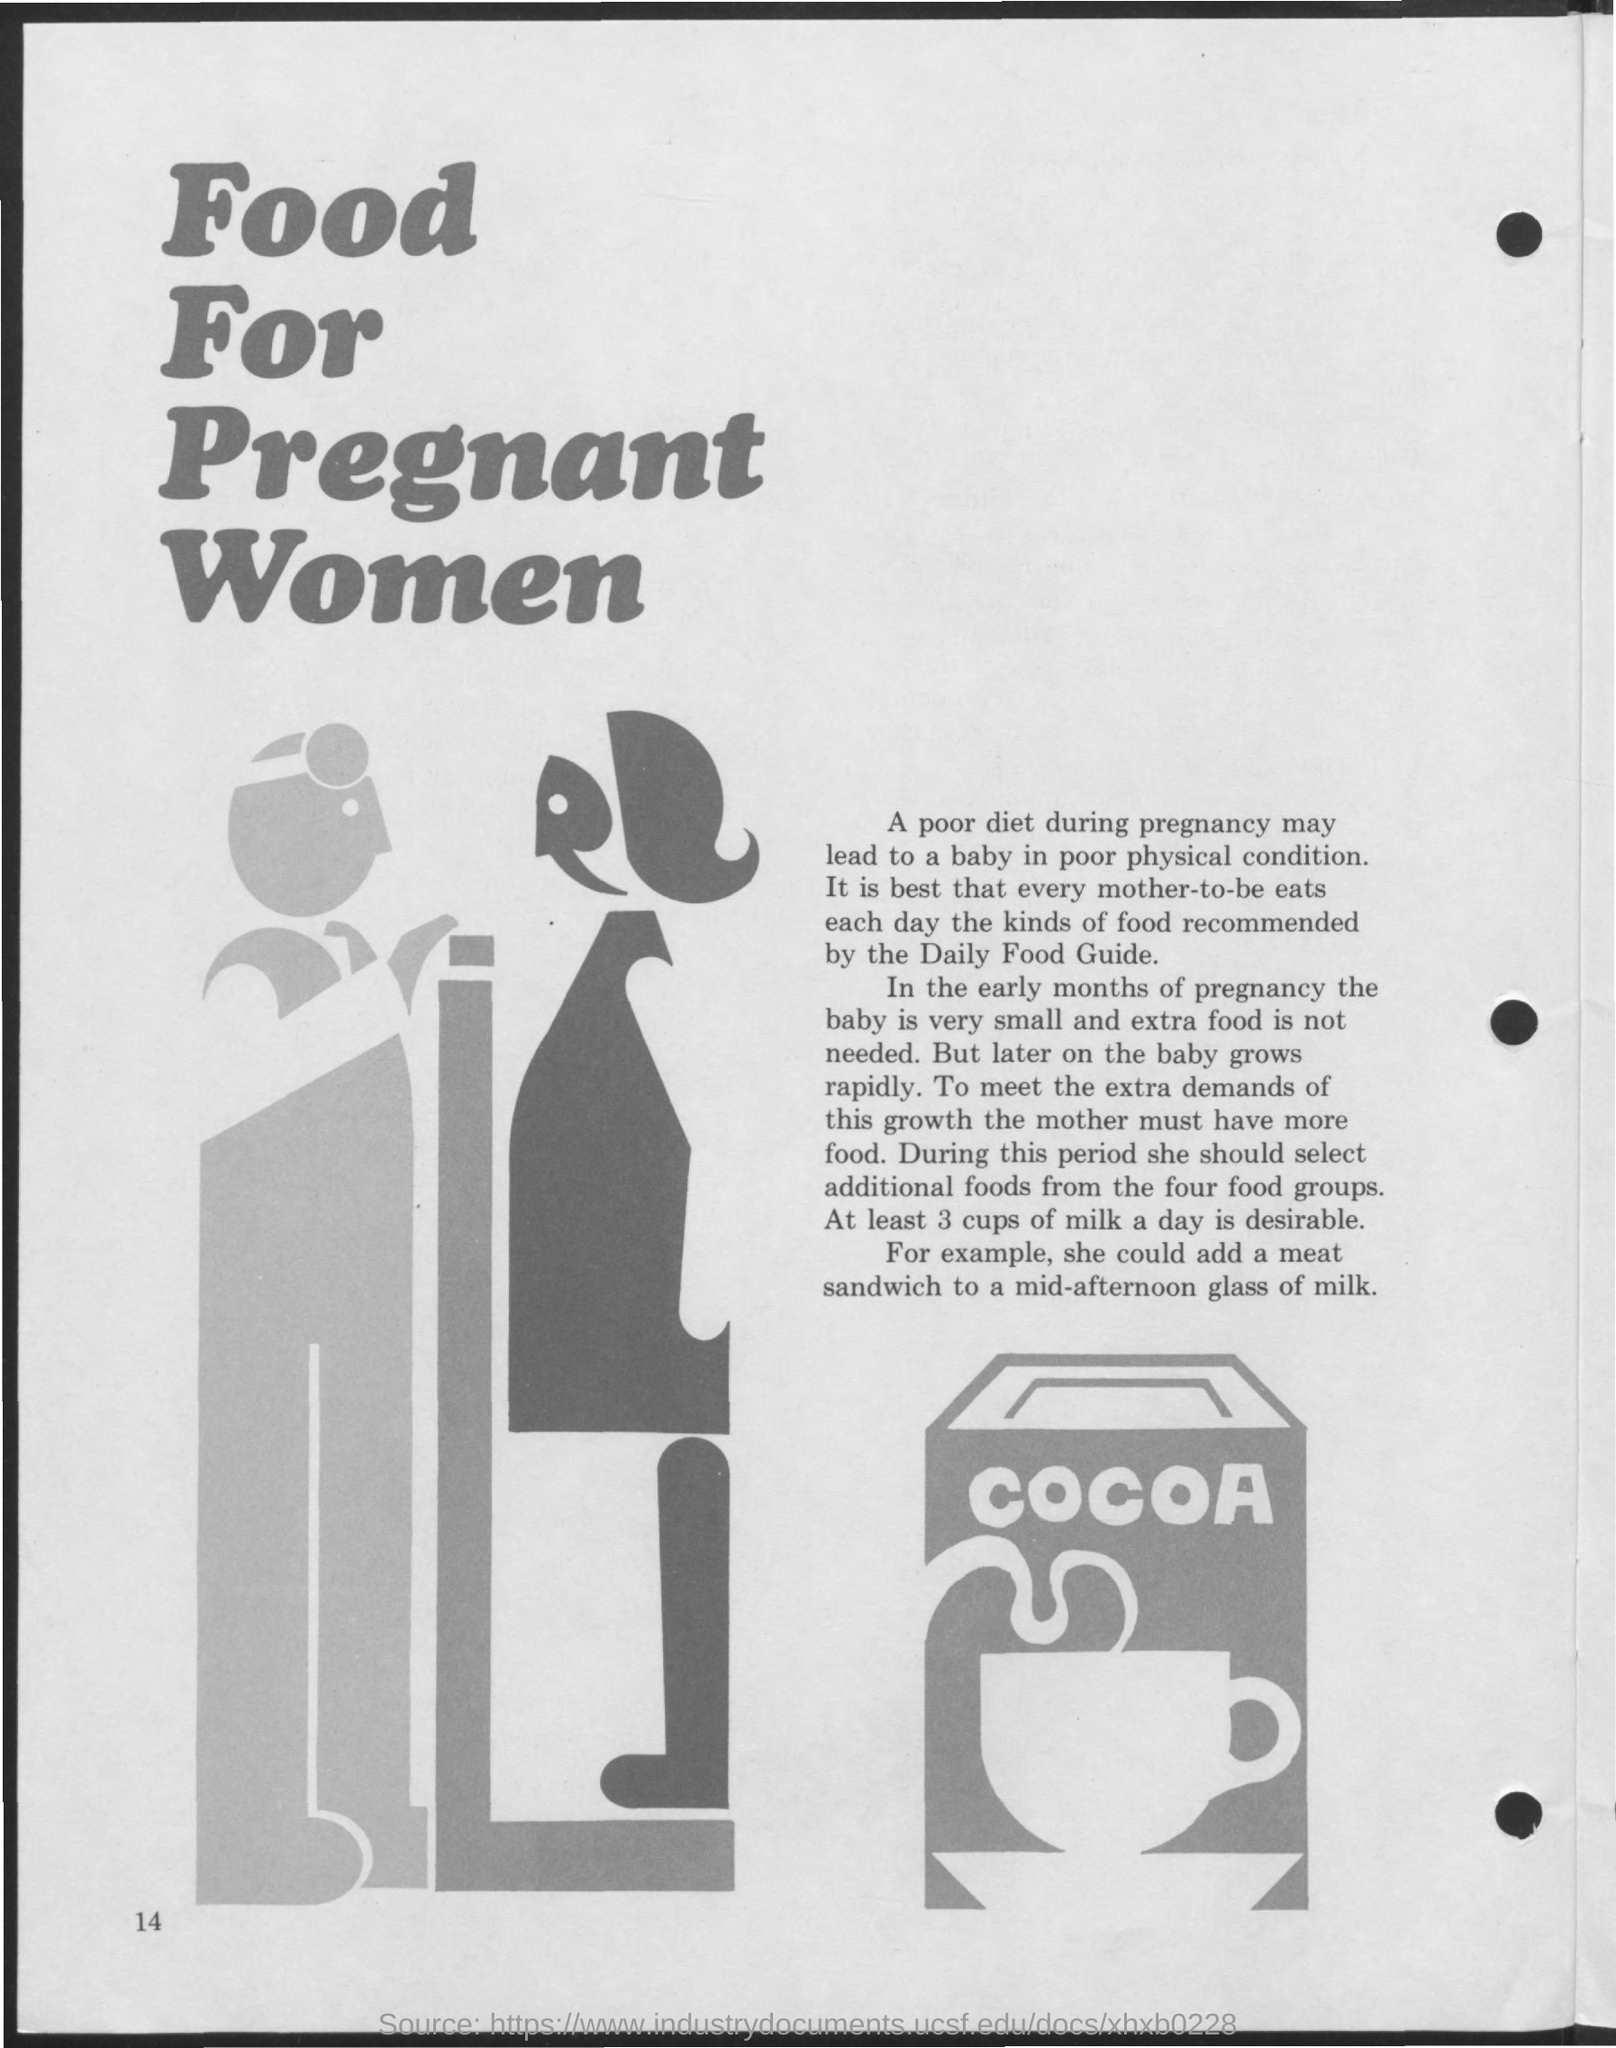Give some essential details in this illustration. The title of the document is 'Food for Pregnant Women.' It is recommended that an individual consumes three cups of milk each day. 